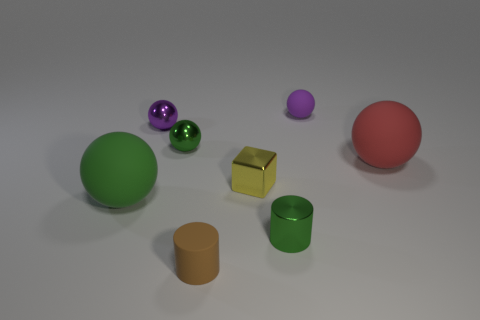What is the material of the large object that is the same color as the metal cylinder?
Provide a succinct answer. Rubber. What number of matte spheres have the same color as the metal cylinder?
Offer a very short reply. 1. What number of things are either small spheres in front of the purple matte thing or big things that are on the right side of the small green shiny cylinder?
Your answer should be very brief. 3. There is a shiny sphere that is right of the tiny purple metal thing; what number of small metal things are to the right of it?
Make the answer very short. 2. What color is the other tiny object that is made of the same material as the tiny brown thing?
Give a very brief answer. Purple. Is there a yellow metallic thing of the same size as the brown matte cylinder?
Provide a short and direct response. Yes. There is a purple metallic object that is the same size as the brown rubber cylinder; what shape is it?
Your answer should be compact. Sphere. Are there any large yellow metal things that have the same shape as the tiny yellow metal object?
Your answer should be compact. No. Is the material of the red sphere the same as the yellow cube that is left of the small purple rubber object?
Your answer should be very brief. No. Is there another matte cylinder that has the same color as the matte cylinder?
Ensure brevity in your answer.  No. 